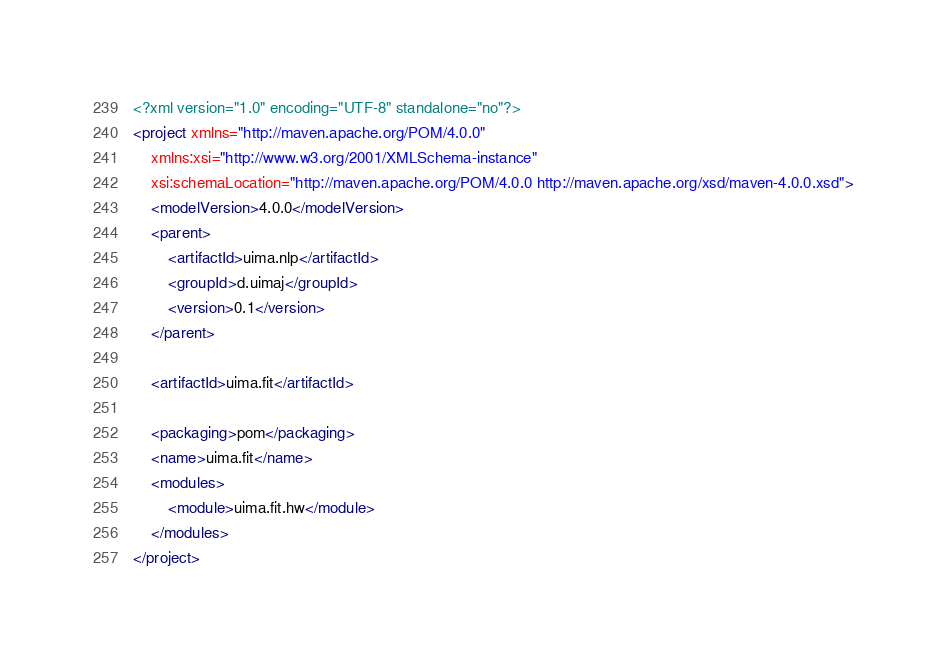<code> <loc_0><loc_0><loc_500><loc_500><_XML_><?xml version="1.0" encoding="UTF-8" standalone="no"?>
<project xmlns="http://maven.apache.org/POM/4.0.0"
	xmlns:xsi="http://www.w3.org/2001/XMLSchema-instance"
	xsi:schemaLocation="http://maven.apache.org/POM/4.0.0 http://maven.apache.org/xsd/maven-4.0.0.xsd">
	<modelVersion>4.0.0</modelVersion>
	<parent>
		<artifactId>uima.nlp</artifactId>
		<groupId>d.uimaj</groupId>
		<version>0.1</version>
	</parent>

	<artifactId>uima.fit</artifactId>

	<packaging>pom</packaging>
	<name>uima.fit</name>
	<modules>
		<module>uima.fit.hw</module>
	</modules>
</project>
</code> 